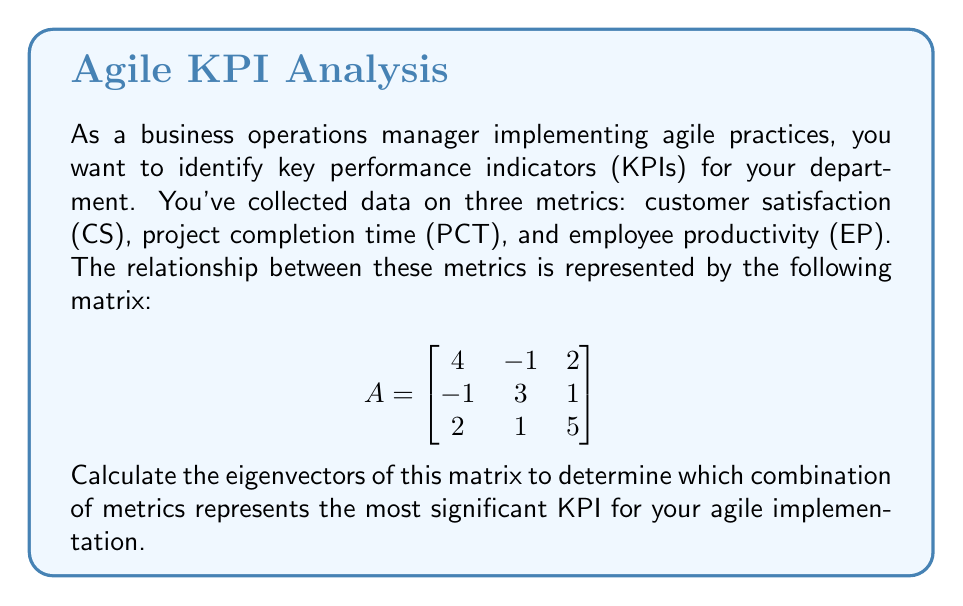Can you solve this math problem? To find the eigenvectors, we'll follow these steps:

1) First, we need to find the eigenvalues by solving the characteristic equation:
   $\det(A - \lambda I) = 0$

2) Expand the determinant:
   $$\begin{vmatrix}
   4-\lambda & -1 & 2 \\
   -1 & 3-\lambda & 1 \\
   2 & 1 & 5-\lambda
   \end{vmatrix} = 0$$

3) This gives us the characteristic polynomial:
   $(4-\lambda)(3-\lambda)(5-\lambda) + (-1)(1)(2) + (2)(1)(-1) - (2)(3-\lambda)(2) - (4-\lambda)(1)(1) - (-1)(-1)(5-\lambda) = 0$

4) Simplify:
   $\lambda^3 - 12\lambda^2 + 41\lambda - 40 = 0$

5) The roots of this polynomial are the eigenvalues. They are:
   $\lambda_1 = 2$, $\lambda_2 = 5$, $\lambda_3 = 5$

6) Now, for each eigenvalue, we solve $(A - \lambda I)v = 0$ to find the corresponding eigenvector.

7) For $\lambda_1 = 2$:
   $$\begin{bmatrix}
   2 & -1 & 2 \\
   -1 & 1 & 1 \\
   2 & 1 & 3
   \end{bmatrix} \begin{bmatrix} v_1 \\ v_2 \\ v_3 \end{bmatrix} = \begin{bmatrix} 0 \\ 0 \\ 0 \end{bmatrix}$$

   Solving this gives us: $v_1 = \begin{bmatrix} 1 \\ 1 \\ -1 \end{bmatrix}$

8) For $\lambda_2 = \lambda_3 = 5$:
   $$\begin{bmatrix}
   -1 & -1 & 2 \\
   -1 & -2 & 1 \\
   2 & 1 & 0
   \end{bmatrix} \begin{bmatrix} v_1 \\ v_2 \\ v_3 \end{bmatrix} = \begin{bmatrix} 0 \\ 0 \\ 0 \end{bmatrix}$$

   Solving this gives us two linearly independent eigenvectors:
   $v_2 = \begin{bmatrix} 2 \\ -1 \\ 1 \end{bmatrix}$ and $v_3 = \begin{bmatrix} 1 \\ 1 \\ 1 \end{bmatrix}$

9) The eigenvector with the largest eigenvalue (5) represents the most significant KPI. In this case, we have two eigenvectors for $\lambda = 5$, so both are equally important.
Answer: The most significant KPIs are represented by $\begin{bmatrix} 2 \\ -1 \\ 1 \end{bmatrix}$ and $\begin{bmatrix} 1 \\ 1 \\ 1 \end{bmatrix}$, corresponding to weighted combinations of CS, PCT, and EP. 